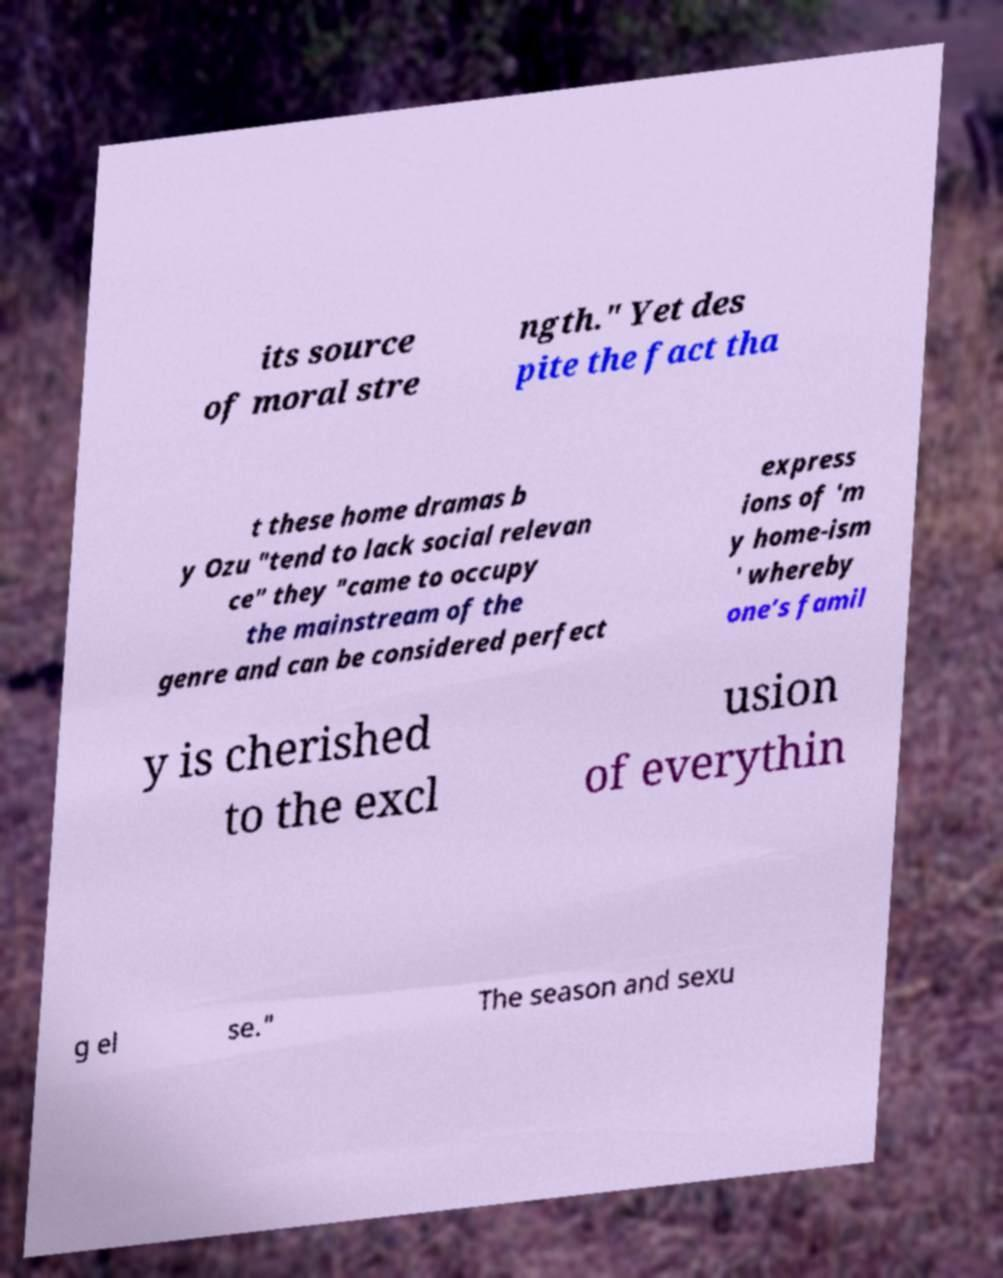There's text embedded in this image that I need extracted. Can you transcribe it verbatim? its source of moral stre ngth." Yet des pite the fact tha t these home dramas b y Ozu "tend to lack social relevan ce" they "came to occupy the mainstream of the genre and can be considered perfect express ions of 'm y home-ism ' whereby one’s famil y is cherished to the excl usion of everythin g el se." The season and sexu 